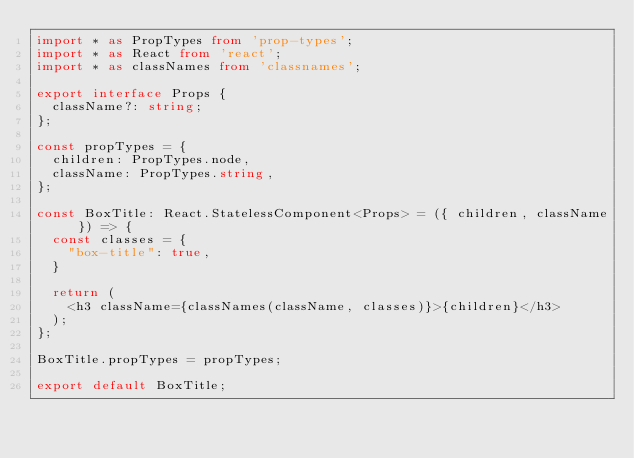Convert code to text. <code><loc_0><loc_0><loc_500><loc_500><_TypeScript_>import * as PropTypes from 'prop-types';
import * as React from 'react';
import * as classNames from 'classnames';

export interface Props {
  className?: string;
};

const propTypes = {
  children: PropTypes.node,
  className: PropTypes.string,
};

const BoxTitle: React.StatelessComponent<Props> = ({ children, className }) => {
  const classes = {
    "box-title": true,
  }

  return (
    <h3 className={classNames(className, classes)}>{children}</h3>
  );
};

BoxTitle.propTypes = propTypes;

export default BoxTitle;
</code> 